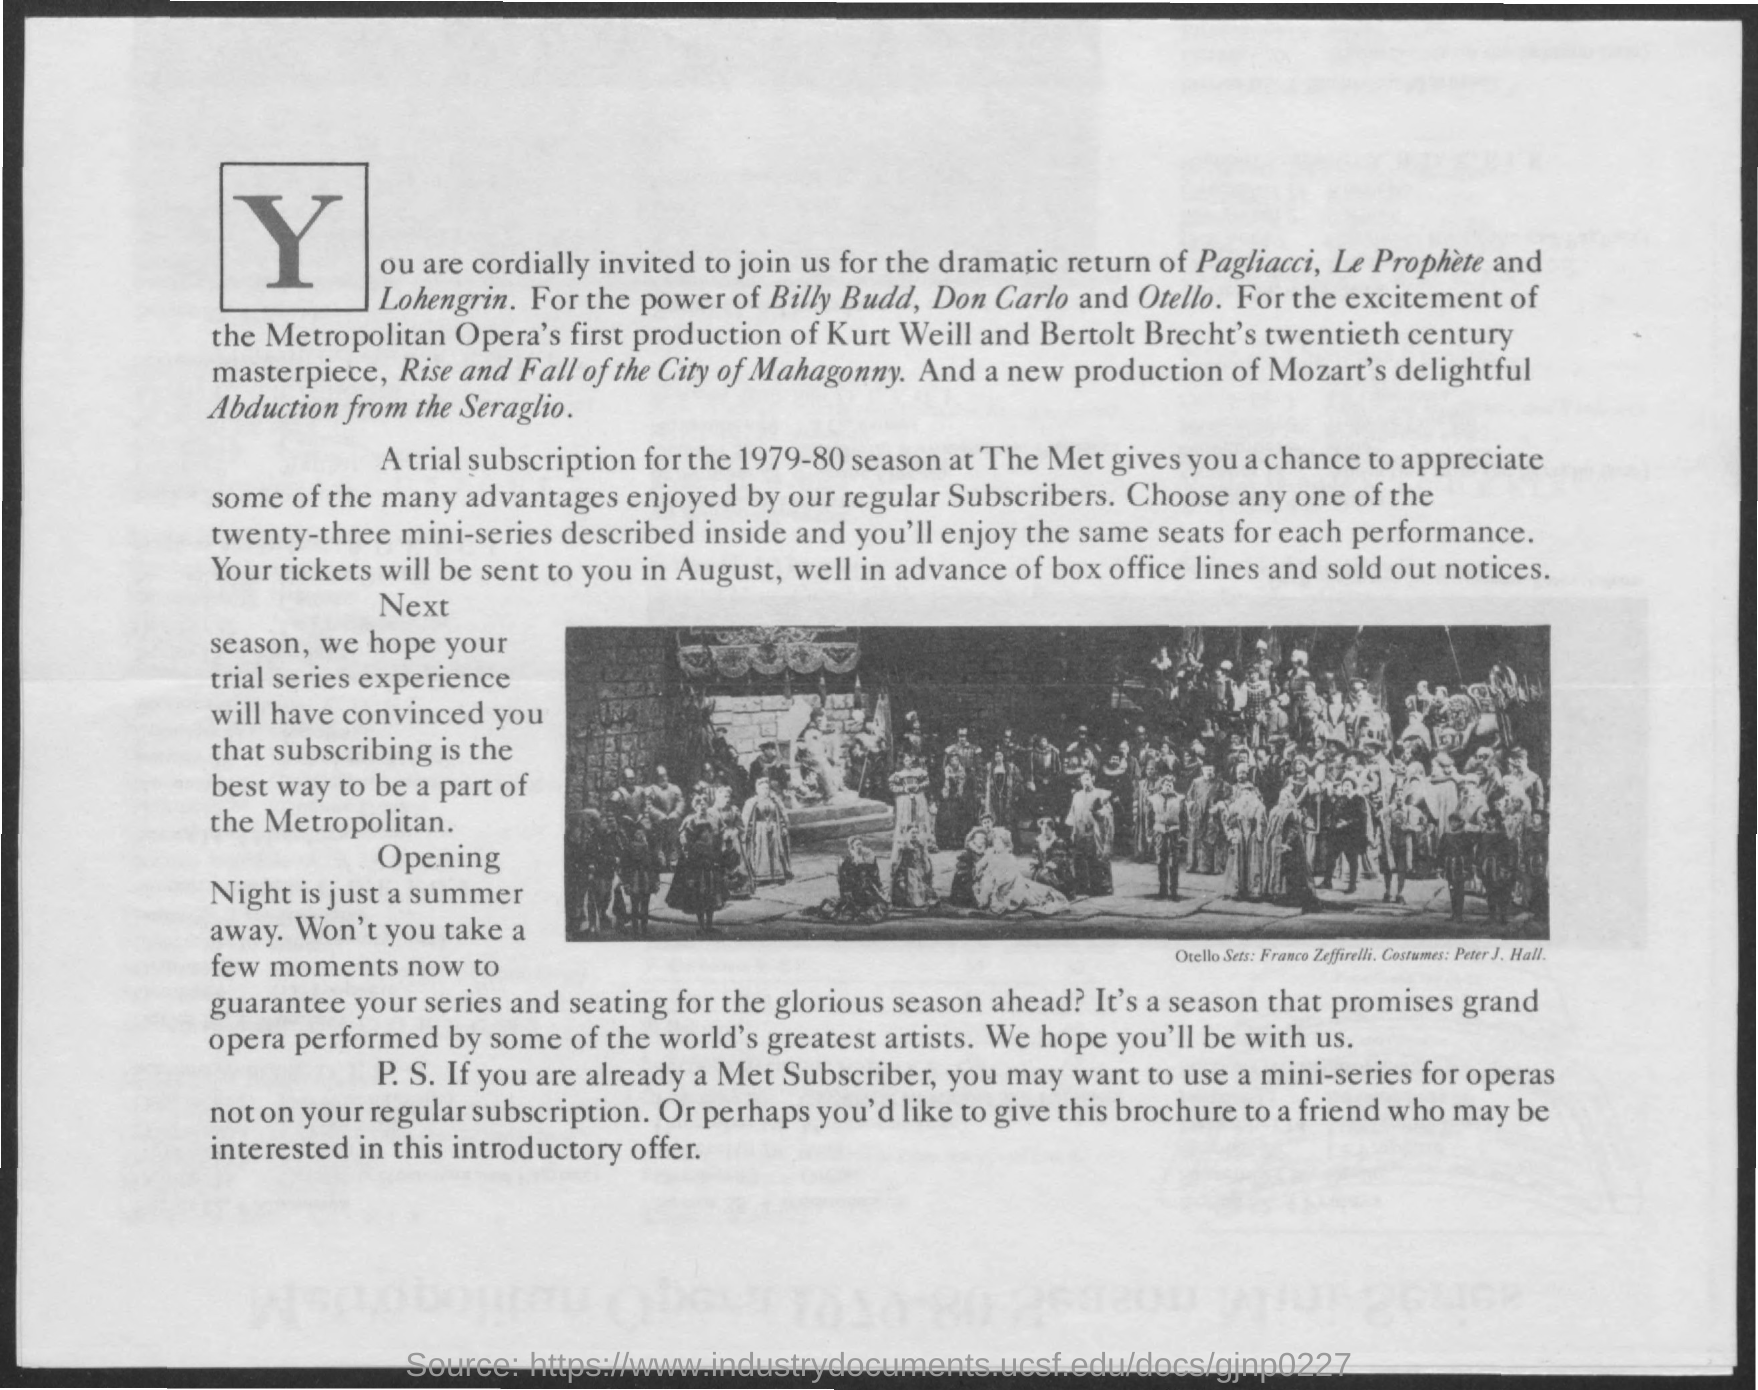Highlight a few significant elements in this photo. What was just a summer away has now become Opening Night. Met subscribers were granted the privilege of using a mini-series for operas as an additional benefit, not included in their regular subscription. In August, the tickets will be sent in advance and sold out notices will not be necessary. The Met performed a trail subscription during the 1979-80 season. The letter that is shown in large fonts at the beginning of the document is "Y. 